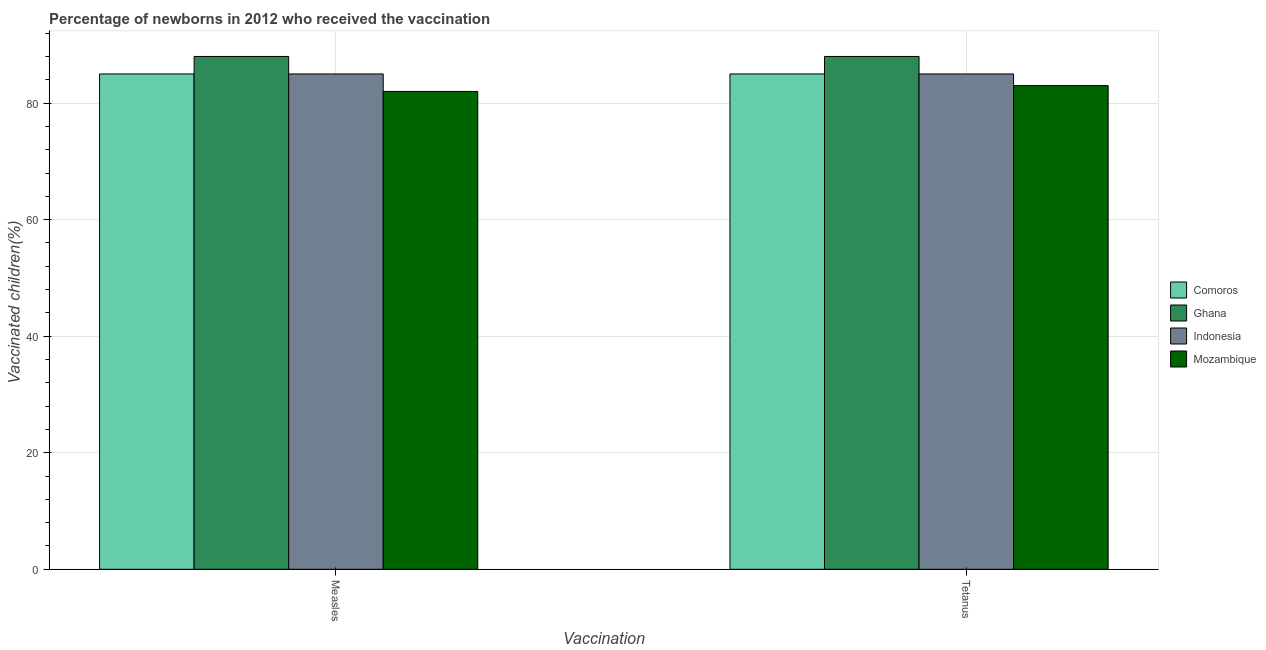How many different coloured bars are there?
Keep it short and to the point. 4. How many groups of bars are there?
Offer a very short reply. 2. Are the number of bars per tick equal to the number of legend labels?
Offer a terse response. Yes. Are the number of bars on each tick of the X-axis equal?
Offer a terse response. Yes. How many bars are there on the 1st tick from the left?
Ensure brevity in your answer.  4. What is the label of the 2nd group of bars from the left?
Keep it short and to the point. Tetanus. What is the percentage of newborns who received vaccination for measles in Indonesia?
Make the answer very short. 85. Across all countries, what is the maximum percentage of newborns who received vaccination for measles?
Keep it short and to the point. 88. Across all countries, what is the minimum percentage of newborns who received vaccination for measles?
Your answer should be very brief. 82. In which country was the percentage of newborns who received vaccination for measles maximum?
Keep it short and to the point. Ghana. In which country was the percentage of newborns who received vaccination for tetanus minimum?
Your response must be concise. Mozambique. What is the total percentage of newborns who received vaccination for measles in the graph?
Keep it short and to the point. 340. What is the difference between the percentage of newborns who received vaccination for measles in Indonesia and that in Mozambique?
Give a very brief answer. 3. What is the difference between the percentage of newborns who received vaccination for measles in Mozambique and the percentage of newborns who received vaccination for tetanus in Comoros?
Provide a short and direct response. -3. What is the difference between the percentage of newborns who received vaccination for measles and percentage of newborns who received vaccination for tetanus in Mozambique?
Offer a terse response. -1. In how many countries, is the percentage of newborns who received vaccination for tetanus greater than 76 %?
Offer a terse response. 4. What is the ratio of the percentage of newborns who received vaccination for measles in Ghana to that in Mozambique?
Give a very brief answer. 1.07. In how many countries, is the percentage of newborns who received vaccination for tetanus greater than the average percentage of newborns who received vaccination for tetanus taken over all countries?
Ensure brevity in your answer.  1. What does the 4th bar from the right in Measles represents?
Your answer should be very brief. Comoros. How many bars are there?
Provide a short and direct response. 8. Are all the bars in the graph horizontal?
Your response must be concise. No. How many countries are there in the graph?
Ensure brevity in your answer.  4. What is the difference between two consecutive major ticks on the Y-axis?
Provide a succinct answer. 20. Where does the legend appear in the graph?
Provide a succinct answer. Center right. How many legend labels are there?
Provide a short and direct response. 4. How are the legend labels stacked?
Offer a very short reply. Vertical. What is the title of the graph?
Provide a succinct answer. Percentage of newborns in 2012 who received the vaccination. Does "Netherlands" appear as one of the legend labels in the graph?
Your response must be concise. No. What is the label or title of the X-axis?
Provide a succinct answer. Vaccination. What is the label or title of the Y-axis?
Give a very brief answer. Vaccinated children(%)
. What is the Vaccinated children(%)
 in Comoros in Measles?
Ensure brevity in your answer.  85. What is the Vaccinated children(%)
 of Mozambique in Measles?
Provide a succinct answer. 82. What is the Vaccinated children(%)
 of Ghana in Tetanus?
Ensure brevity in your answer.  88. What is the Vaccinated children(%)
 of Indonesia in Tetanus?
Your response must be concise. 85. Across all Vaccination, what is the maximum Vaccinated children(%)
 of Indonesia?
Offer a very short reply. 85. Across all Vaccination, what is the maximum Vaccinated children(%)
 in Mozambique?
Make the answer very short. 83. Across all Vaccination, what is the minimum Vaccinated children(%)
 in Comoros?
Offer a terse response. 85. Across all Vaccination, what is the minimum Vaccinated children(%)
 in Indonesia?
Ensure brevity in your answer.  85. What is the total Vaccinated children(%)
 in Comoros in the graph?
Provide a short and direct response. 170. What is the total Vaccinated children(%)
 in Ghana in the graph?
Make the answer very short. 176. What is the total Vaccinated children(%)
 in Indonesia in the graph?
Your response must be concise. 170. What is the total Vaccinated children(%)
 of Mozambique in the graph?
Your answer should be very brief. 165. What is the difference between the Vaccinated children(%)
 in Comoros in Measles and that in Tetanus?
Your answer should be very brief. 0. What is the difference between the Vaccinated children(%)
 of Mozambique in Measles and that in Tetanus?
Your response must be concise. -1. What is the difference between the Vaccinated children(%)
 in Comoros in Measles and the Vaccinated children(%)
 in Ghana in Tetanus?
Your answer should be very brief. -3. What is the difference between the Vaccinated children(%)
 in Comoros in Measles and the Vaccinated children(%)
 in Indonesia in Tetanus?
Offer a terse response. 0. What is the difference between the Vaccinated children(%)
 of Comoros in Measles and the Vaccinated children(%)
 of Mozambique in Tetanus?
Provide a short and direct response. 2. What is the difference between the Vaccinated children(%)
 in Ghana in Measles and the Vaccinated children(%)
 in Indonesia in Tetanus?
Provide a short and direct response. 3. What is the difference between the Vaccinated children(%)
 in Ghana in Measles and the Vaccinated children(%)
 in Mozambique in Tetanus?
Offer a very short reply. 5. What is the difference between the Vaccinated children(%)
 of Indonesia in Measles and the Vaccinated children(%)
 of Mozambique in Tetanus?
Your response must be concise. 2. What is the average Vaccinated children(%)
 of Comoros per Vaccination?
Keep it short and to the point. 85. What is the average Vaccinated children(%)
 of Ghana per Vaccination?
Offer a terse response. 88. What is the average Vaccinated children(%)
 of Indonesia per Vaccination?
Your answer should be compact. 85. What is the average Vaccinated children(%)
 in Mozambique per Vaccination?
Provide a short and direct response. 82.5. What is the difference between the Vaccinated children(%)
 in Comoros and Vaccinated children(%)
 in Indonesia in Measles?
Give a very brief answer. 0. What is the difference between the Vaccinated children(%)
 of Comoros and Vaccinated children(%)
 of Mozambique in Measles?
Your answer should be very brief. 3. What is the difference between the Vaccinated children(%)
 of Indonesia and Vaccinated children(%)
 of Mozambique in Measles?
Provide a succinct answer. 3. What is the difference between the Vaccinated children(%)
 in Ghana and Vaccinated children(%)
 in Mozambique in Tetanus?
Provide a short and direct response. 5. What is the ratio of the Vaccinated children(%)
 in Mozambique in Measles to that in Tetanus?
Offer a terse response. 0.99. What is the difference between the highest and the second highest Vaccinated children(%)
 of Comoros?
Provide a succinct answer. 0. What is the difference between the highest and the second highest Vaccinated children(%)
 in Ghana?
Offer a terse response. 0. What is the difference between the highest and the second highest Vaccinated children(%)
 in Indonesia?
Ensure brevity in your answer.  0. What is the difference between the highest and the second highest Vaccinated children(%)
 in Mozambique?
Keep it short and to the point. 1. What is the difference between the highest and the lowest Vaccinated children(%)
 in Mozambique?
Provide a short and direct response. 1. 